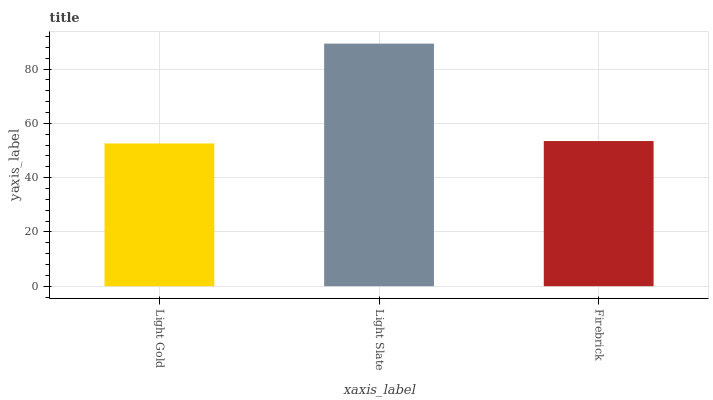Is Light Gold the minimum?
Answer yes or no. Yes. Is Light Slate the maximum?
Answer yes or no. Yes. Is Firebrick the minimum?
Answer yes or no. No. Is Firebrick the maximum?
Answer yes or no. No. Is Light Slate greater than Firebrick?
Answer yes or no. Yes. Is Firebrick less than Light Slate?
Answer yes or no. Yes. Is Firebrick greater than Light Slate?
Answer yes or no. No. Is Light Slate less than Firebrick?
Answer yes or no. No. Is Firebrick the high median?
Answer yes or no. Yes. Is Firebrick the low median?
Answer yes or no. Yes. Is Light Slate the high median?
Answer yes or no. No. Is Light Gold the low median?
Answer yes or no. No. 